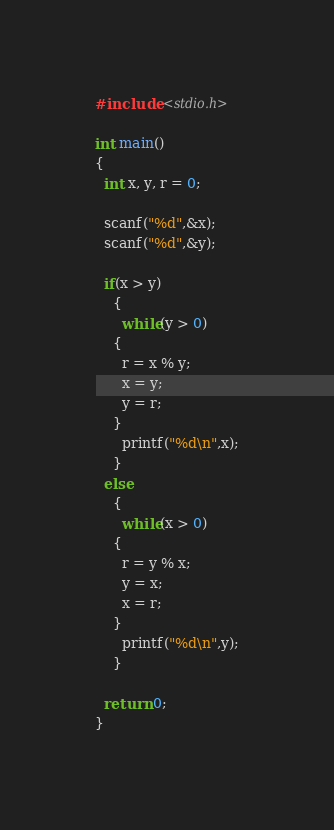<code> <loc_0><loc_0><loc_500><loc_500><_C_>#include <stdio.h>

int main()
{
  int x, y, r = 0;

  scanf("%d",&x);
  scanf("%d",&y);

  if(x > y)
    {
      while(y > 0)
	{
	  r = x % y;
	  x = y;
	  y = r;
	}
      printf("%d\n",x);
    }
  else
    {
      while(x > 0)
	{
	  r = y % x;
	  y = x;
	  x = r;
	}
      printf("%d\n",y);
    }
  
  return 0;
}

</code> 